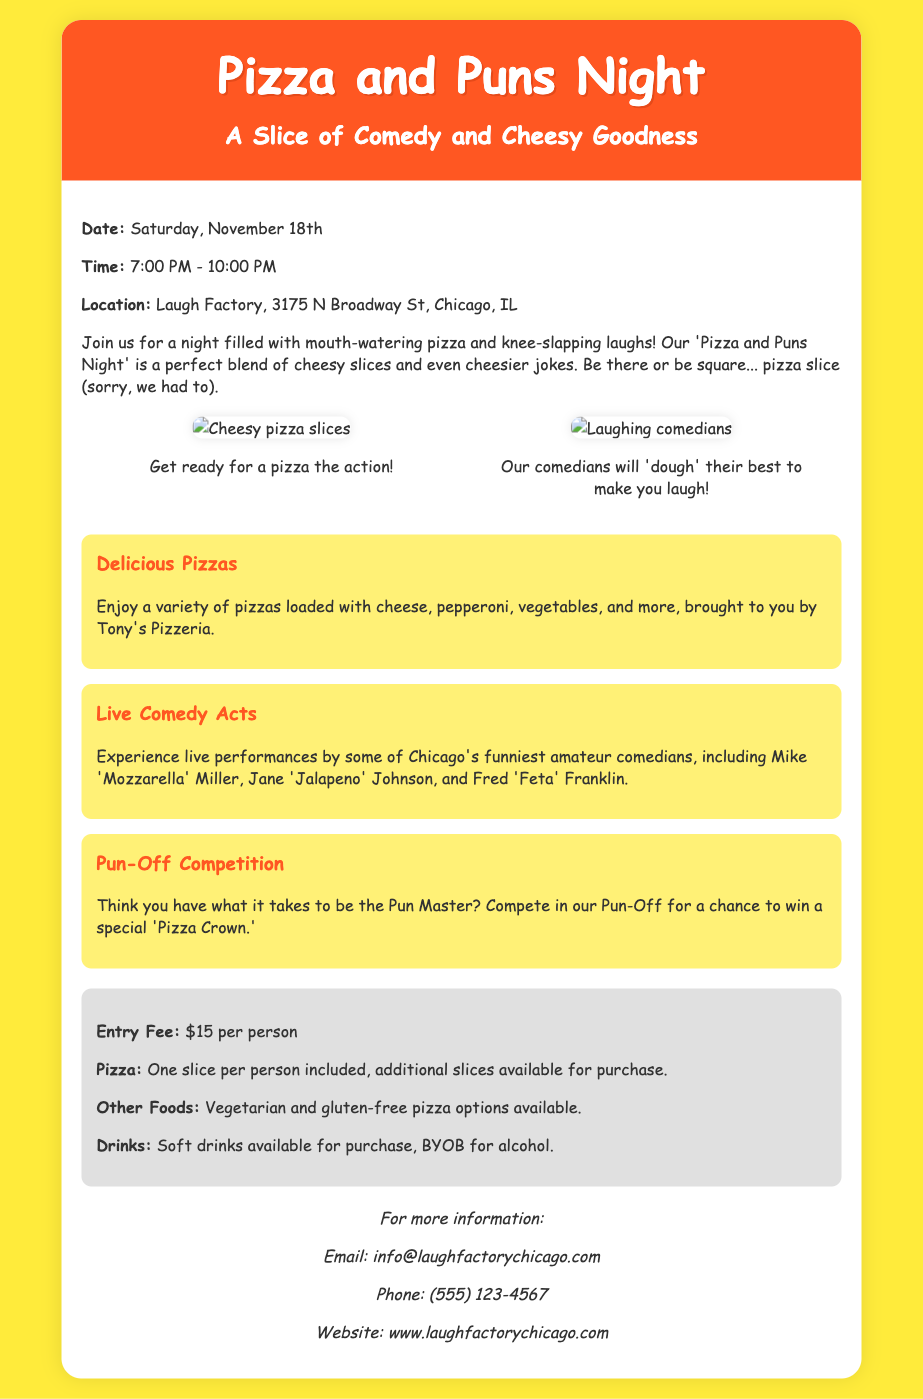what is the date of the event? The document states that the event will take place on Saturday, November 18th.
Answer: Saturday, November 18th what time does the event start? The flyer mentions that the event begins at 7:00 PM.
Answer: 7:00 PM where is the event located? According to the document, the event location is Laugh Factory, 3175 N Broadway St, Chicago, IL.
Answer: Laugh Factory, 3175 N Broadway St, Chicago, IL how much is the entry fee? The document specifies the entry fee as $15 per person.
Answer: $15 per person who is one of the comedians performing? The flyer lists Mike 'Mozzarella' Miller as one of the comedians.
Answer: Mike 'Mozzarella' Miller what do attendees compete for in the Pun-Off? The document states that participants can compete for a special 'Pizza Crown.'
Answer: 'Pizza Crown' what type of pizza options are available? The flyer mentions that there are vegetarian and gluten-free pizza options available.
Answer: Vegetarian and gluten-free how long will the event last? The document indicates that the event will run from 7:00 PM to 10:00 PM, which is three hours.
Answer: Three hours 